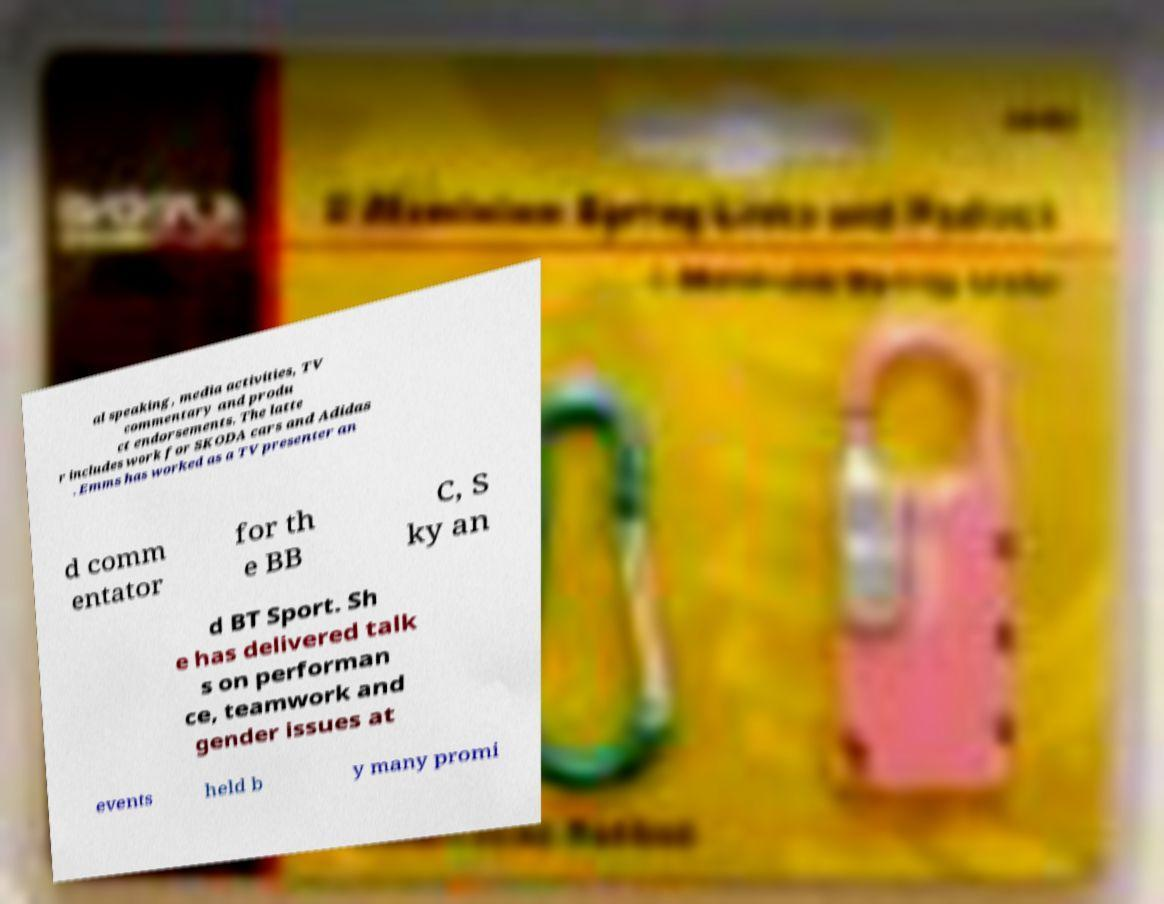For documentation purposes, I need the text within this image transcribed. Could you provide that? al speaking, media activities, TV commentary and produ ct endorsements. The latte r includes work for SKODA cars and Adidas . Emms has worked as a TV presenter an d comm entator for th e BB C, S ky an d BT Sport. Sh e has delivered talk s on performan ce, teamwork and gender issues at events held b y many promi 